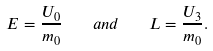<formula> <loc_0><loc_0><loc_500><loc_500>E = \frac { U _ { 0 } } { m _ { 0 } } \quad a n d \quad L = \frac { U _ { 3 } } { m _ { 0 } } .</formula> 